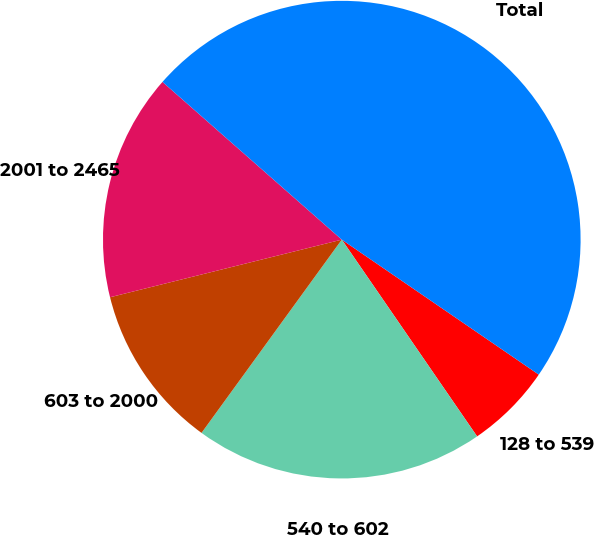Convert chart to OTSL. <chart><loc_0><loc_0><loc_500><loc_500><pie_chart><fcel>128 to 539<fcel>540 to 602<fcel>603 to 2000<fcel>2001 to 2465<fcel>Total<nl><fcel>5.85%<fcel>19.58%<fcel>11.13%<fcel>15.36%<fcel>48.08%<nl></chart> 